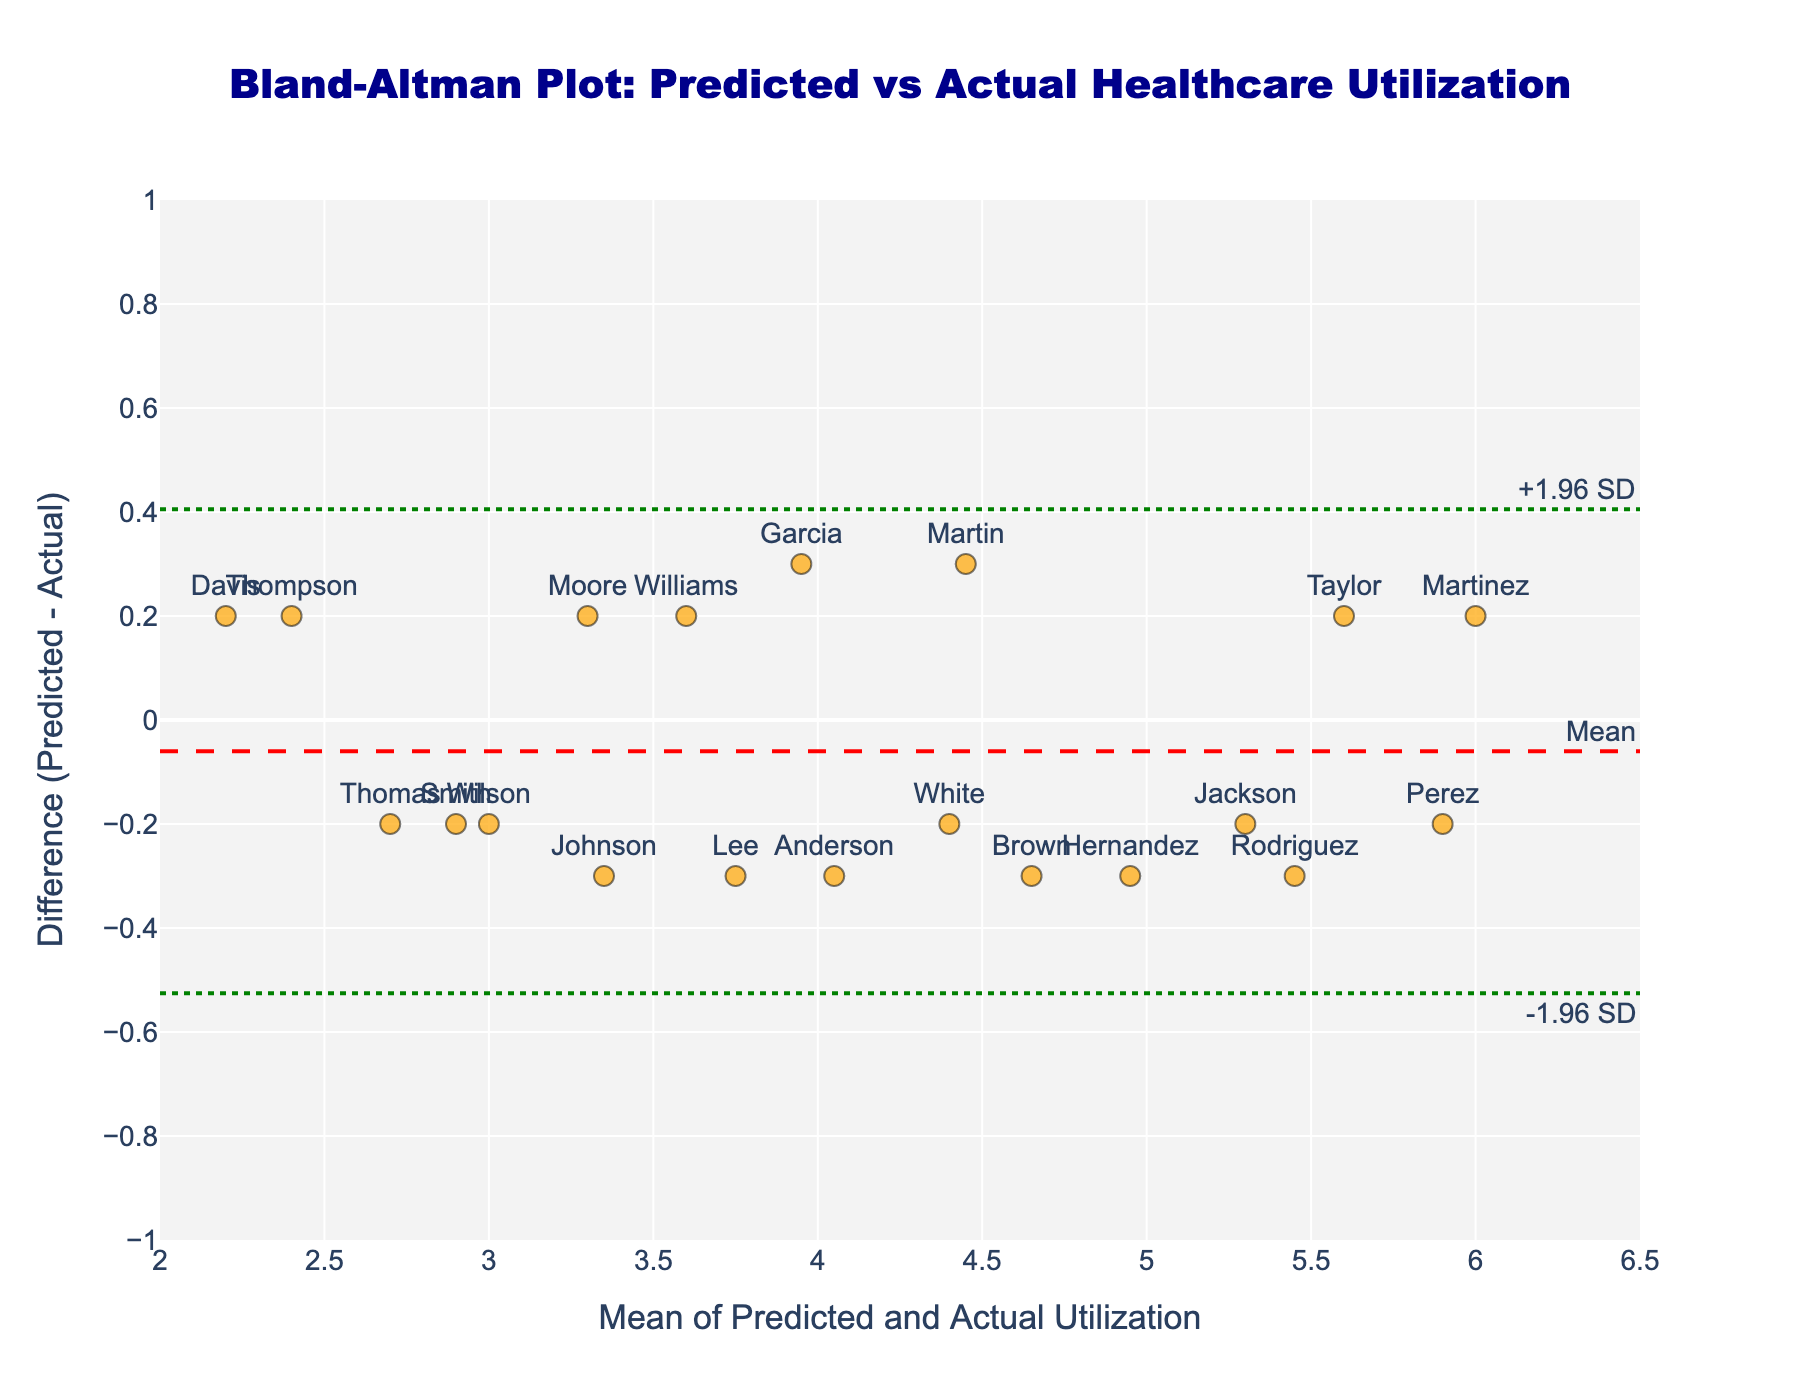what is the title of the plot? The title is located at the top of the plot and clearly states what is being presented. From the visual, we see the text at the top saying "Bland-Altman Plot: Predicted vs Actual Healthcare Utilization".
Answer: Bland-Altman Plot: Predicted vs Actual Healthcare Utilization How many families are represented by data points in the plot? Each data point is labeled with a family ID, which represents each family. By counting the markers or family names, we can see there are 20 families shown in the plot.
Answer: 20 What is the mean difference between predicted and actual healthcare utilization? The mean difference can be identified from the horizontal dashed red line labeled "Mean". The plot visually indicates this difference line is at 0, as it runs horizontally through the center of the data points.
Answer: 0 What is the range of the x-axis? The x-axis runs from the minimum mean value to the maximum mean value of the healthcare utilization data. From the visual tick marks, it is clear the range is from 2.0 to 6.5.
Answer: 2.0 to 6.5 Which family has the highest positive difference between predicted and actual utilization? The family with the highest positive difference has the highest point on the y-axis. Observing the plot, the highest positive difference point is labeled "Wilson".
Answer: Wilson What are the upper and lower limits of agreement? Limits of agreement are visually represented by horizontal dotted green lines labeled "+1.96 SD" and "-1.96 SD". These lines are at approximately 0.3 and -0.3 respectively.
Answer: +0.3 and -0.3 Which family has the closest predicted utilization to the actual utilization? The point closest to the y-axis zero line (i.e., where the difference is smallest) indicates close predicted and actual utilization. The closest point visually is labeled "Wilson".
Answer: Wilson What is the mean utilization for the family labeled "Brown"? To find the mean, locate "Brown" on the plot. Brown's data point aligns approximately at 4.65 on the x-axis as seen on the plot.
Answer: 4.65 How does the utilization mean of family "Perez" compare to "Martinez"? Locate the points labeled "Perez" and "Martinez." "Perez" is around 5.9 on the x-axis, while "Martinez" is at about 6.0. Thus, "Perez" has a slightly lower utilization mean than "Martinez".
Answer: Perez is slightly lower than Martinez Are the differences between predicted and actual utilizations generally within the limits of agreement? Observing the scatter plot, most points fall between the upper and lower limits of agreement (the green dotted lines at +0.3 and -0.3), indicating differences are generally within this range.
Answer: Yes 